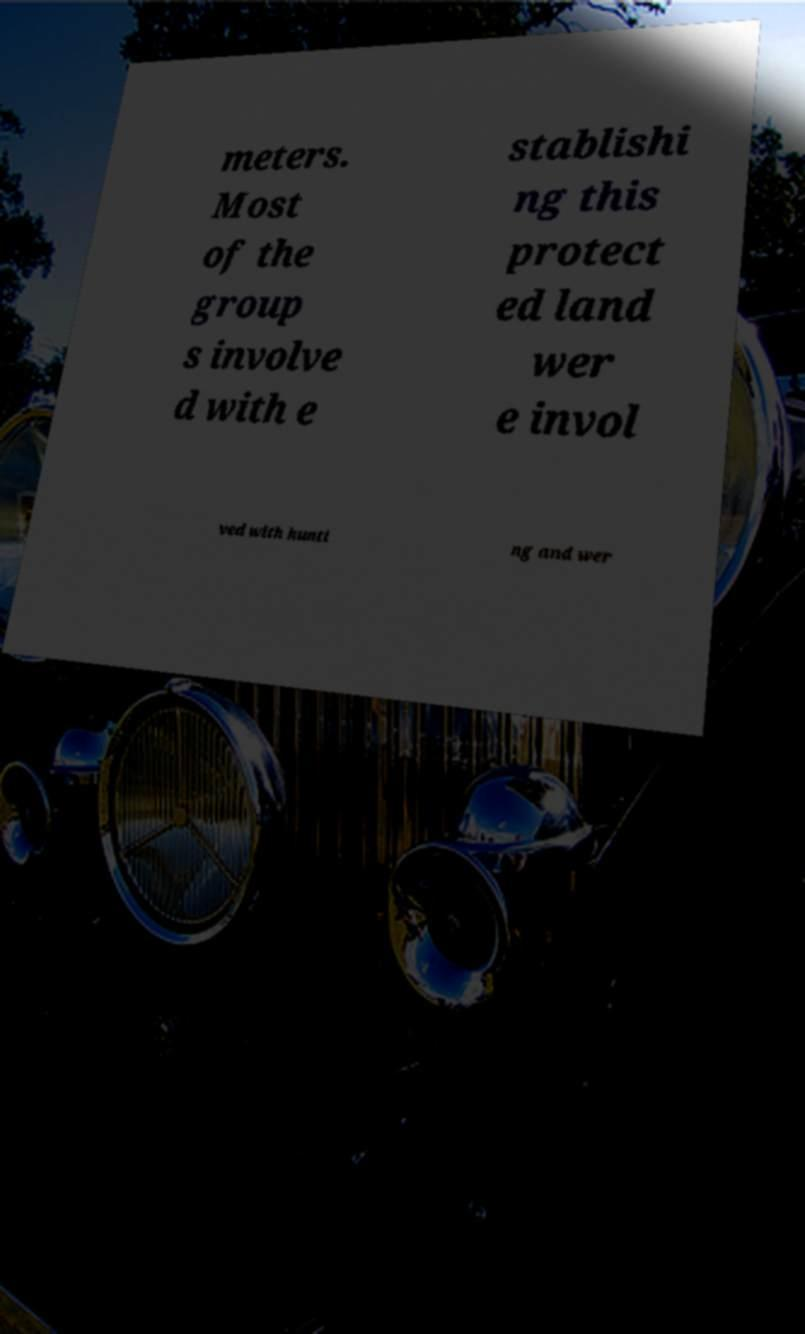Please identify and transcribe the text found in this image. meters. Most of the group s involve d with e stablishi ng this protect ed land wer e invol ved with hunti ng and wer 